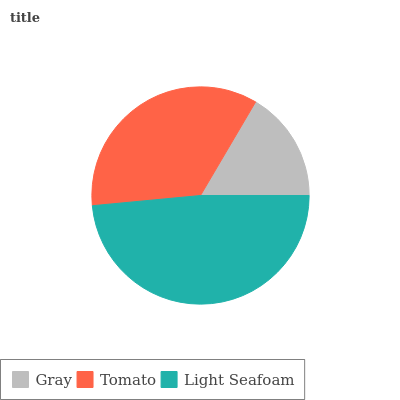Is Gray the minimum?
Answer yes or no. Yes. Is Light Seafoam the maximum?
Answer yes or no. Yes. Is Tomato the minimum?
Answer yes or no. No. Is Tomato the maximum?
Answer yes or no. No. Is Tomato greater than Gray?
Answer yes or no. Yes. Is Gray less than Tomato?
Answer yes or no. Yes. Is Gray greater than Tomato?
Answer yes or no. No. Is Tomato less than Gray?
Answer yes or no. No. Is Tomato the high median?
Answer yes or no. Yes. Is Tomato the low median?
Answer yes or no. Yes. Is Light Seafoam the high median?
Answer yes or no. No. Is Light Seafoam the low median?
Answer yes or no. No. 